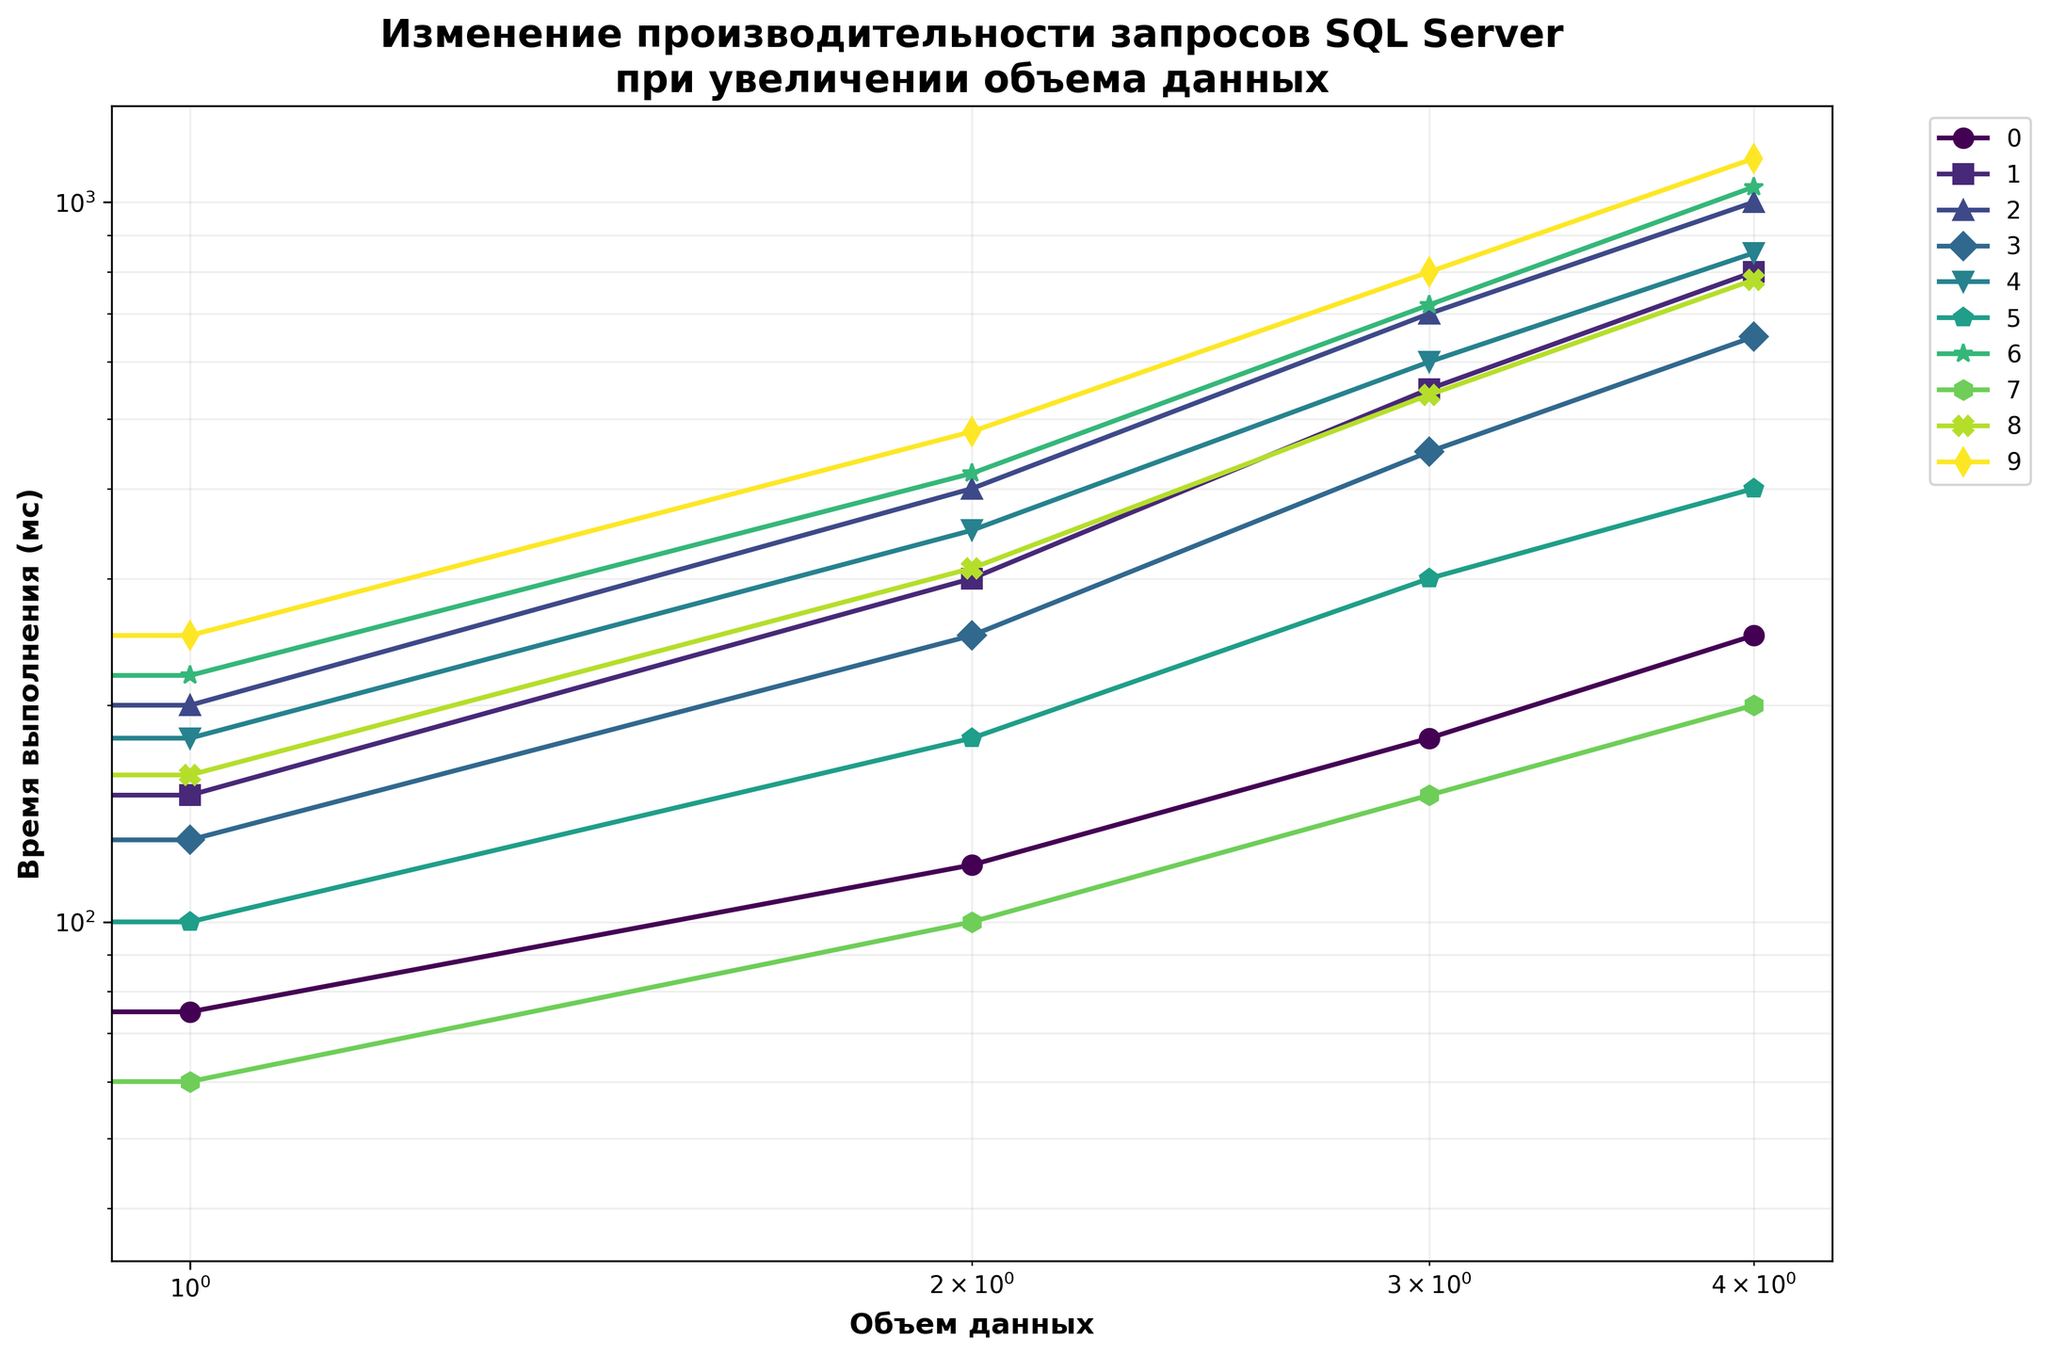Which query type has the highest execution time at 1TB? To determine this, find the line that reaches the highest point on the y-axis at the 1TB mark. The "Запрос с курсором" reaches 1150ms, the highest value at 1TB.
Answer: Запрос с курсором (1150мс) Which query type shows the least increase in execution time from 1GB to 1TB? Calculate the difference in execution time from 1GB to 1TB for each query type. The query type with the smallest difference is "Запрос с индексированным представлением", increasing only from 40ms to 200ms (a difference of 160ms).
Answer: Запрос с индексированным представлением (160мс) What's the average execution time for the "SELECT с простым WHERE" query across all data volumes? Sum the execution times for "SELECT с простым WHERE": 50 + 75 + 120 + 180 + 250. Then, divide by the number of data points (5). The average is (50+75+120+180+250)/5 = 135ms.
Answer: 135мс Which query type has the smallest execution time at 100GB? Check the execution times for all query types at the 100GB mark. The "Запрос с индексированным представлением" is at 100ms, the smallest value.
Answer: Запрос с индексированным представлением (100мс) At what data volume does the "Агрегация с GROUP BY" query type surpass 700ms? Locate the execution times for the "Агрегация с GROUP BY" query type and find where it exceeds 700ms. This occurs at 500GB and 1TB (700ms and 1000ms respectively). The earliest is at 500GB.
Answer: 500GB Compare the execution times of "Запрос с CLR функцией" and "Оконная функция" at 500GB. Which one is faster? Check the y-axis values for both queries at 500GB. "Запрос с CLR функцией" has 720ms, while "Оконная функция" has 600ms. "Оконная функция" is faster.
Answer: Оконная функция (600мс) Estimate the difference in execution time between "Подзапрос в SELECT" and "JOIN двух таблиц" at 100GB. Subtract the 100GB execution times of "JOIN двух таблиц" (300ms) from "Подзапрос в SELECT" (250ms). The difference is 250ms - 300ms = -50ms.
Answer: -50мс Which query types have an execution time greater than 700ms at 1TB? Identify all the values greater than 700ms at 1TB: "SELECT с простым WHERE" (250ms), "JOIN двух таблиц" (800ms), "Агрегация с GROUP BY" (1000ms), "Подзапрос в SELECT" (650ms), "Оконная функция" (850ms), "Запрос с CLR функцией" (1050ms), "Запрос с индексированным представлением" (200ms), "Запрос с динамическим SQL" (780ms), and "Запрос с курсором" (1150ms). The relevant queries are: "JOIN двух таблиц" (800ms), "Агрегация с GROUP BY" (1000ms), "Оконная функция" (850ms), "Запрос с CLR функцией" (1050ms), "Запрос с динамическим SQL" (780ms), and "Запрос с курсором" (1150ms).
Answer: JOIN двух таблиц, Агрегация с GROUP BY, Оконная функция, Запрос с CLR функцией, Запрос с динамическим SQL, Запрос с курсором How many query types have execution times exceeding 400ms at 100GB? Count the number of query types with a value greater than 400ms at 100GB. The following values were checked: SELECT с простым WHERE (120ms), JOIN двух таблиц (300ms), Агрегация с GROUP BY (400ms), Подзапрос в SELECT (250ms), Оконная функция (350ms), Полнотекстовый поиск (180ms), Запрос с CLR функцией (420ms), Запрос с индексированным представлением (100ms), Запрос с динамическим SQL (310ms), Запрос с курсором (480ms). Only "Запрос с CLR функцией" and "Запрос с курсором" exceed 400ms.
Answer: 2 